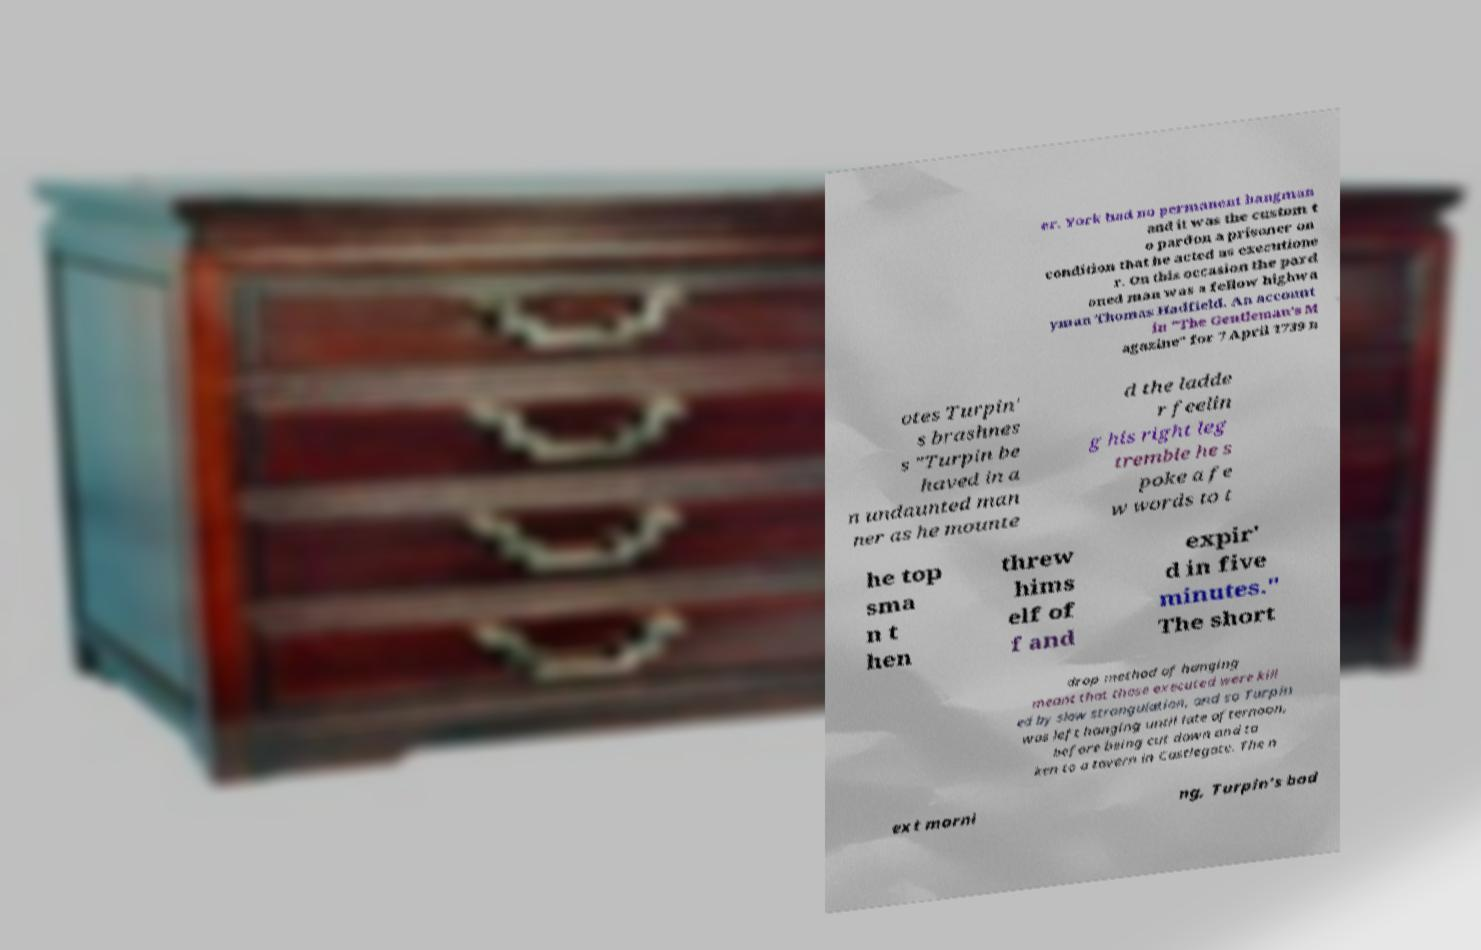Could you assist in decoding the text presented in this image and type it out clearly? er. York had no permanent hangman and it was the custom t o pardon a prisoner on condition that he acted as executione r. On this occasion the pard oned man was a fellow highwa yman Thomas Hadfield. An account in "The Gentleman's M agazine" for 7 April 1739 n otes Turpin' s brashnes s "Turpin be haved in a n undaunted man ner as he mounte d the ladde r feelin g his right leg tremble he s poke a fe w words to t he top sma n t hen threw hims elf of f and expir' d in five minutes." The short drop method of hanging meant that those executed were kill ed by slow strangulation, and so Turpin was left hanging until late afternoon, before being cut down and ta ken to a tavern in Castlegate. The n ext morni ng, Turpin's bod 